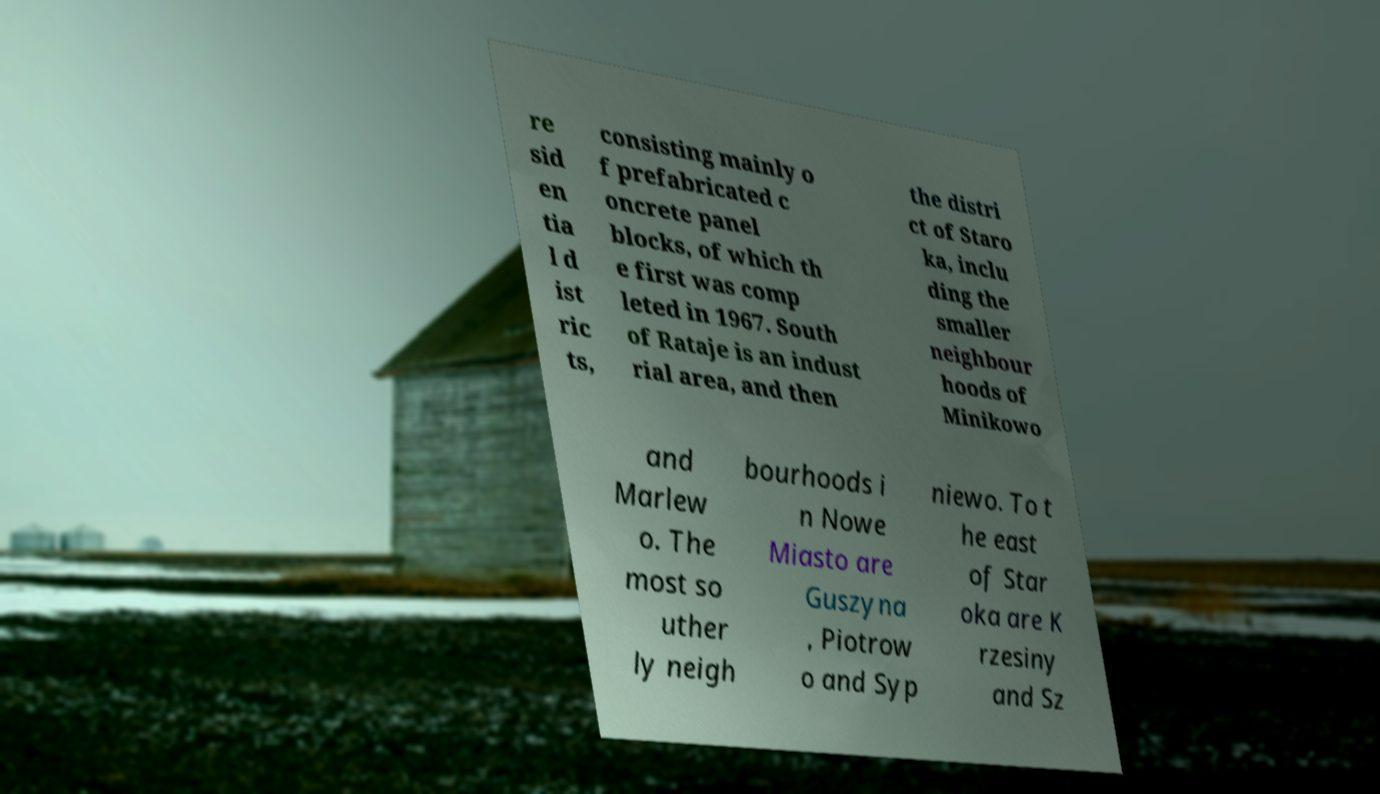Could you extract and type out the text from this image? re sid en tia l d ist ric ts, consisting mainly o f prefabricated c oncrete panel blocks, of which th e first was comp leted in 1967. South of Rataje is an indust rial area, and then the distri ct of Staro ka, inclu ding the smaller neighbour hoods of Minikowo and Marlew o. The most so uther ly neigh bourhoods i n Nowe Miasto are Guszyna , Piotrow o and Syp niewo. To t he east of Star oka are K rzesiny and Sz 